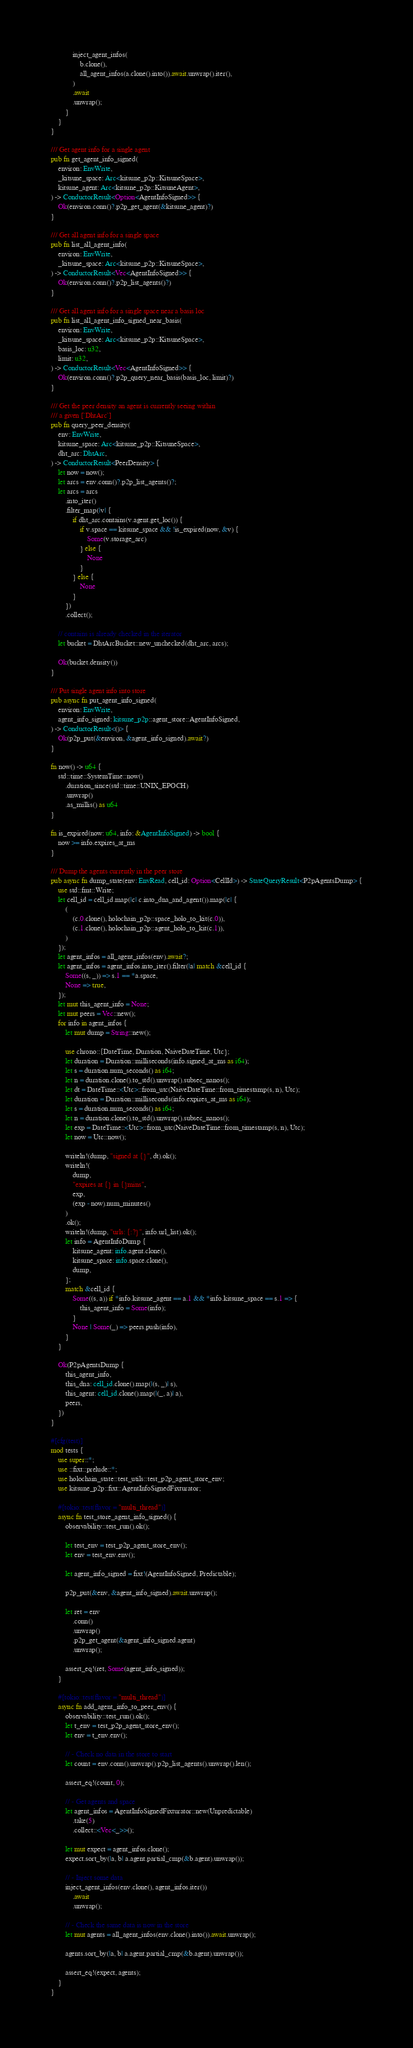<code> <loc_0><loc_0><loc_500><loc_500><_Rust_>            inject_agent_infos(
                b.clone(),
                all_agent_infos(a.clone().into()).await.unwrap().iter(),
            )
            .await
            .unwrap();
        }
    }
}

/// Get agent info for a single agent
pub fn get_agent_info_signed(
    environ: EnvWrite,
    _kitsune_space: Arc<kitsune_p2p::KitsuneSpace>,
    kitsune_agent: Arc<kitsune_p2p::KitsuneAgent>,
) -> ConductorResult<Option<AgentInfoSigned>> {
    Ok(environ.conn()?.p2p_get_agent(&kitsune_agent)?)
}

/// Get all agent info for a single space
pub fn list_all_agent_info(
    environ: EnvWrite,
    _kitsune_space: Arc<kitsune_p2p::KitsuneSpace>,
) -> ConductorResult<Vec<AgentInfoSigned>> {
    Ok(environ.conn()?.p2p_list_agents()?)
}

/// Get all agent info for a single space near a basis loc
pub fn list_all_agent_info_signed_near_basis(
    environ: EnvWrite,
    _kitsune_space: Arc<kitsune_p2p::KitsuneSpace>,
    basis_loc: u32,
    limit: u32,
) -> ConductorResult<Vec<AgentInfoSigned>> {
    Ok(environ.conn()?.p2p_query_near_basis(basis_loc, limit)?)
}

/// Get the peer density an agent is currently seeing within
/// a given [`DhtArc`]
pub fn query_peer_density(
    env: EnvWrite,
    kitsune_space: Arc<kitsune_p2p::KitsuneSpace>,
    dht_arc: DhtArc,
) -> ConductorResult<PeerDensity> {
    let now = now();
    let arcs = env.conn()?.p2p_list_agents()?;
    let arcs = arcs
        .into_iter()
        .filter_map(|v| {
            if dht_arc.contains(v.agent.get_loc()) {
                if v.space == kitsune_space && !is_expired(now, &v) {
                    Some(v.storage_arc)
                } else {
                    None
                }
            } else {
                None
            }
        })
        .collect();

    // contains is already checked in the iterator
    let bucket = DhtArcBucket::new_unchecked(dht_arc, arcs);

    Ok(bucket.density())
}

/// Put single agent info into store
pub async fn put_agent_info_signed(
    environ: EnvWrite,
    agent_info_signed: kitsune_p2p::agent_store::AgentInfoSigned,
) -> ConductorResult<()> {
    Ok(p2p_put(&environ, &agent_info_signed).await?)
}

fn now() -> u64 {
    std::time::SystemTime::now()
        .duration_since(std::time::UNIX_EPOCH)
        .unwrap()
        .as_millis() as u64
}

fn is_expired(now: u64, info: &AgentInfoSigned) -> bool {
    now >= info.expires_at_ms
}

/// Dump the agents currently in the peer store
pub async fn dump_state(env: EnvRead, cell_id: Option<CellId>) -> StateQueryResult<P2pAgentsDump> {
    use std::fmt::Write;
    let cell_id = cell_id.map(|c| c.into_dna_and_agent()).map(|c| {
        (
            (c.0.clone(), holochain_p2p::space_holo_to_kit(c.0)),
            (c.1.clone(), holochain_p2p::agent_holo_to_kit(c.1)),
        )
    });
    let agent_infos = all_agent_infos(env).await?;
    let agent_infos = agent_infos.into_iter().filter(|a| match &cell_id {
        Some((s, _)) => s.1 == *a.space,
        None => true,
    });
    let mut this_agent_info = None;
    let mut peers = Vec::new();
    for info in agent_infos {
        let mut dump = String::new();

        use chrono::{DateTime, Duration, NaiveDateTime, Utc};
        let duration = Duration::milliseconds(info.signed_at_ms as i64);
        let s = duration.num_seconds() as i64;
        let n = duration.clone().to_std().unwrap().subsec_nanos();
        let dt = DateTime::<Utc>::from_utc(NaiveDateTime::from_timestamp(s, n), Utc);
        let duration = Duration::milliseconds(info.expires_at_ms as i64);
        let s = duration.num_seconds() as i64;
        let n = duration.clone().to_std().unwrap().subsec_nanos();
        let exp = DateTime::<Utc>::from_utc(NaiveDateTime::from_timestamp(s, n), Utc);
        let now = Utc::now();

        writeln!(dump, "signed at {}", dt).ok();
        writeln!(
            dump,
            "expires at {} in {}mins",
            exp,
            (exp - now).num_minutes()
        )
        .ok();
        writeln!(dump, "urls: {:?}", info.url_list).ok();
        let info = AgentInfoDump {
            kitsune_agent: info.agent.clone(),
            kitsune_space: info.space.clone(),
            dump,
        };
        match &cell_id {
            Some((s, a)) if *info.kitsune_agent == a.1 && *info.kitsune_space == s.1 => {
                this_agent_info = Some(info);
            }
            None | Some(_) => peers.push(info),
        }
    }

    Ok(P2pAgentsDump {
        this_agent_info,
        this_dna: cell_id.clone().map(|(s, _)| s),
        this_agent: cell_id.clone().map(|(_, a)| a),
        peers,
    })
}

#[cfg(test)]
mod tests {
    use super::*;
    use ::fixt::prelude::*;
    use holochain_state::test_utils::test_p2p_agent_store_env;
    use kitsune_p2p::fixt::AgentInfoSignedFixturator;

    #[tokio::test(flavor = "multi_thread")]
    async fn test_store_agent_info_signed() {
        observability::test_run().ok();

        let test_env = test_p2p_agent_store_env();
        let env = test_env.env();

        let agent_info_signed = fixt!(AgentInfoSigned, Predictable);

        p2p_put(&env, &agent_info_signed).await.unwrap();

        let ret = env
            .conn()
            .unwrap()
            .p2p_get_agent(&agent_info_signed.agent)
            .unwrap();

        assert_eq!(ret, Some(agent_info_signed));
    }

    #[tokio::test(flavor = "multi_thread")]
    async fn add_agent_info_to_peer_env() {
        observability::test_run().ok();
        let t_env = test_p2p_agent_store_env();
        let env = t_env.env();

        // - Check no data in the store to start
        let count = env.conn().unwrap().p2p_list_agents().unwrap().len();

        assert_eq!(count, 0);

        // - Get agents and space
        let agent_infos = AgentInfoSignedFixturator::new(Unpredictable)
            .take(5)
            .collect::<Vec<_>>();

        let mut expect = agent_infos.clone();
        expect.sort_by(|a, b| a.agent.partial_cmp(&b.agent).unwrap());

        // - Inject some data
        inject_agent_infos(env.clone(), agent_infos.iter())
            .await
            .unwrap();

        // - Check the same data is now in the store
        let mut agents = all_agent_infos(env.clone().into()).await.unwrap();

        agents.sort_by(|a, b| a.agent.partial_cmp(&b.agent).unwrap());

        assert_eq!(expect, agents);
    }
}
</code> 